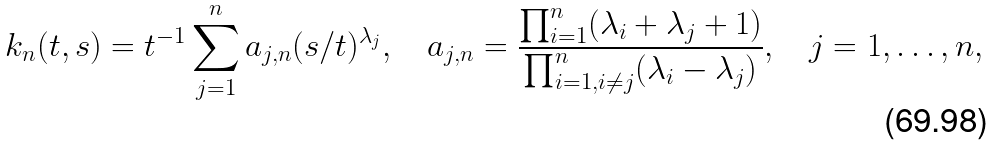<formula> <loc_0><loc_0><loc_500><loc_500>k _ { n } ( t , s ) = t ^ { - 1 } \sum _ { j = 1 } ^ { n } a _ { j , n } ( s / t ) ^ { \lambda _ { j } } , \quad a _ { j , n } = \frac { \prod _ { i = 1 } ^ { n } ( \lambda _ { i } + \lambda _ { j } + 1 ) } { \prod _ { i = 1 , i \neq j } ^ { n } ( \lambda _ { i } - \lambda _ { j } ) } , \quad j = 1 , \dots , n ,</formula> 